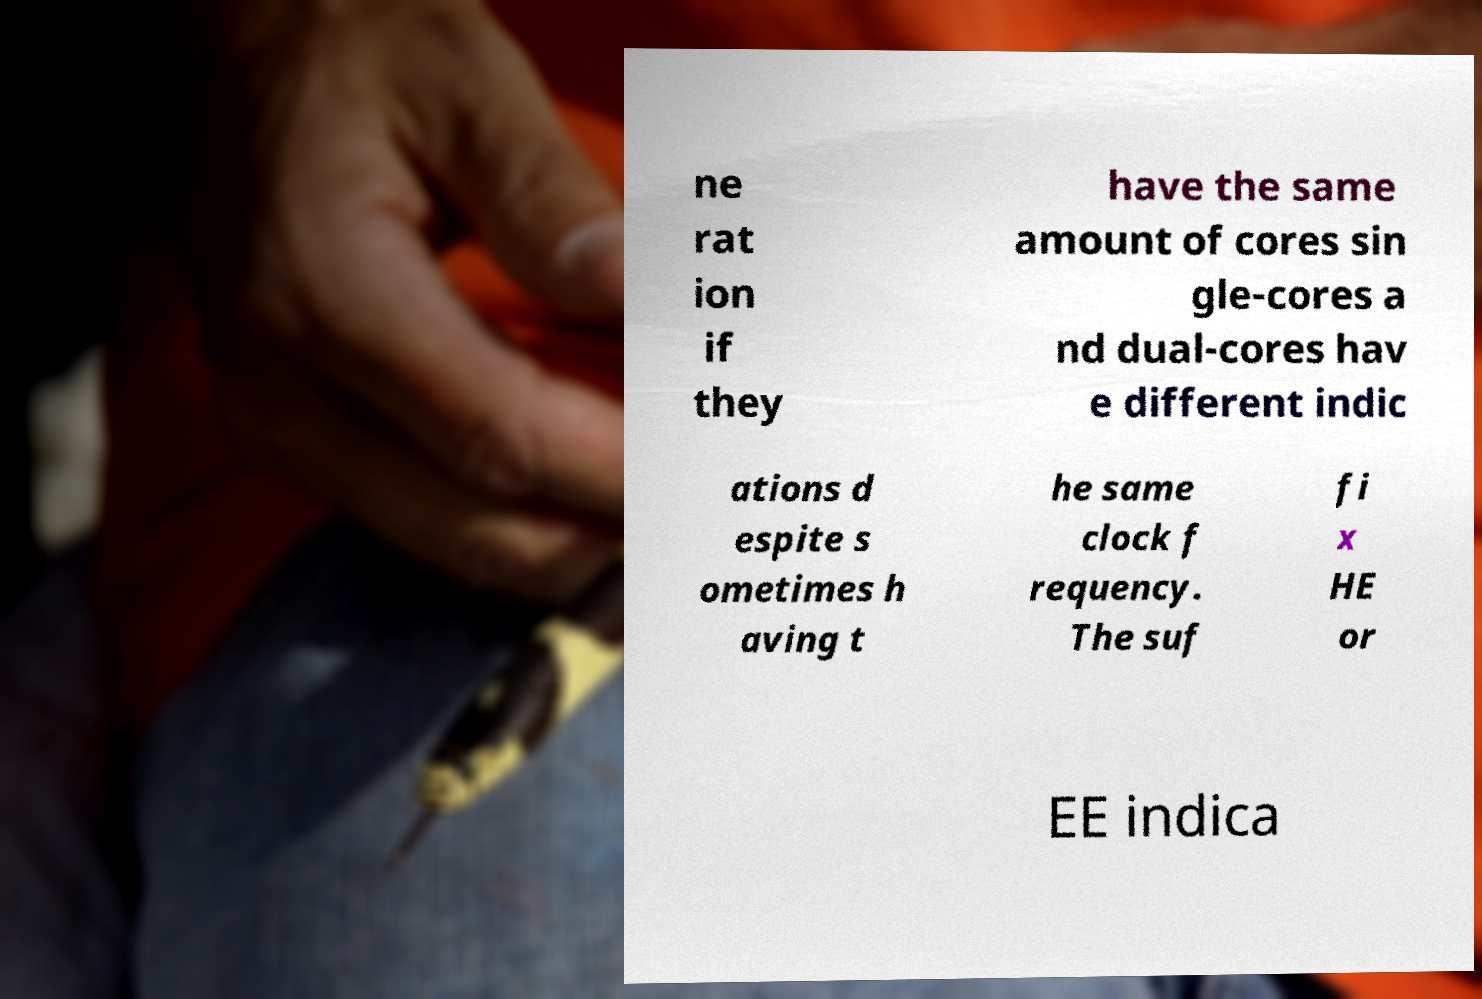I need the written content from this picture converted into text. Can you do that? ne rat ion if they have the same amount of cores sin gle-cores a nd dual-cores hav e different indic ations d espite s ometimes h aving t he same clock f requency. The suf fi x HE or EE indica 